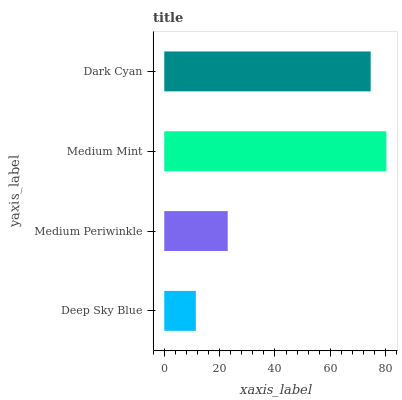Is Deep Sky Blue the minimum?
Answer yes or no. Yes. Is Medium Mint the maximum?
Answer yes or no. Yes. Is Medium Periwinkle the minimum?
Answer yes or no. No. Is Medium Periwinkle the maximum?
Answer yes or no. No. Is Medium Periwinkle greater than Deep Sky Blue?
Answer yes or no. Yes. Is Deep Sky Blue less than Medium Periwinkle?
Answer yes or no. Yes. Is Deep Sky Blue greater than Medium Periwinkle?
Answer yes or no. No. Is Medium Periwinkle less than Deep Sky Blue?
Answer yes or no. No. Is Dark Cyan the high median?
Answer yes or no. Yes. Is Medium Periwinkle the low median?
Answer yes or no. Yes. Is Medium Periwinkle the high median?
Answer yes or no. No. Is Medium Mint the low median?
Answer yes or no. No. 